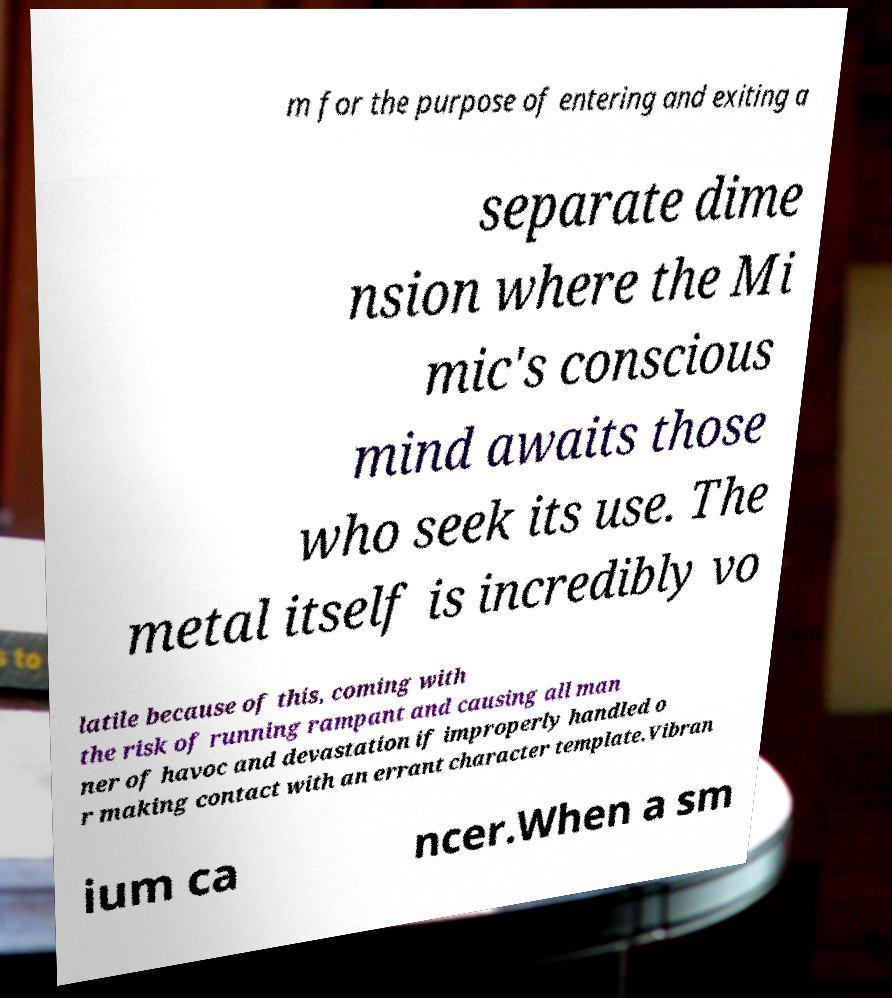Please identify and transcribe the text found in this image. m for the purpose of entering and exiting a separate dime nsion where the Mi mic's conscious mind awaits those who seek its use. The metal itself is incredibly vo latile because of this, coming with the risk of running rampant and causing all man ner of havoc and devastation if improperly handled o r making contact with an errant character template.Vibran ium ca ncer.When a sm 